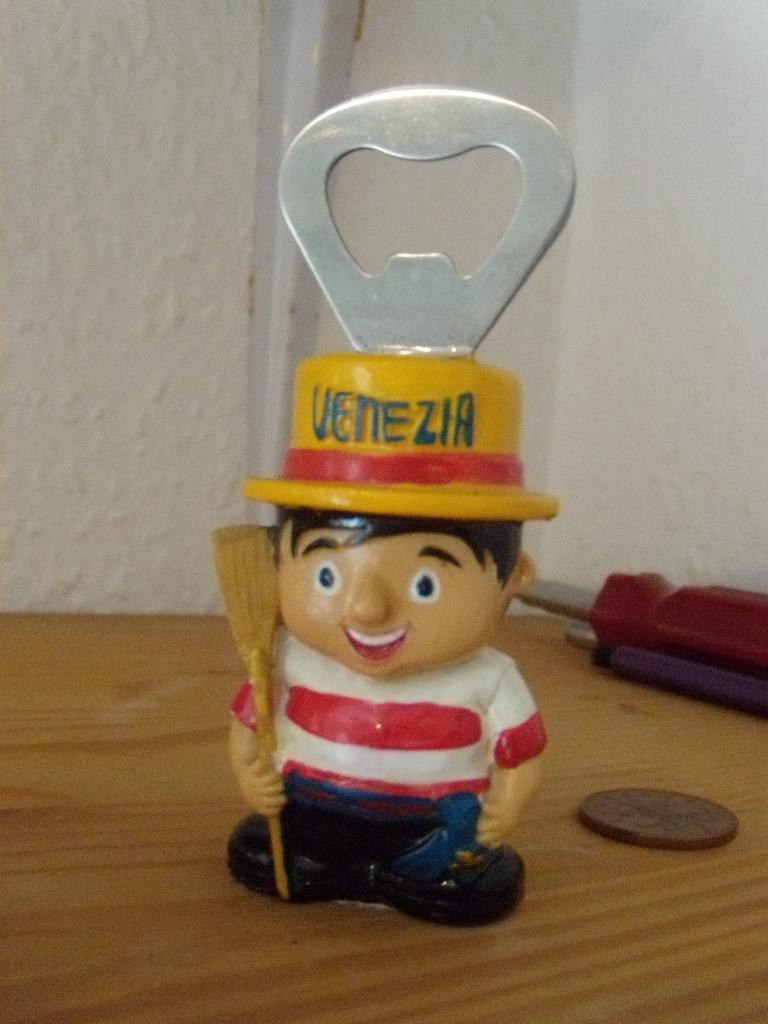What tools are visible in the image? There is an opener and a screwdriver in the image. What other object can be seen in the image? There is a coin in the image. What is visible in the background of the image? There is a wall in the background of the image. How many lizards can be seen crawling on the wall in the image? There are no lizards present in the image; only the opener, screwdriver, coin, and wall are visible. 